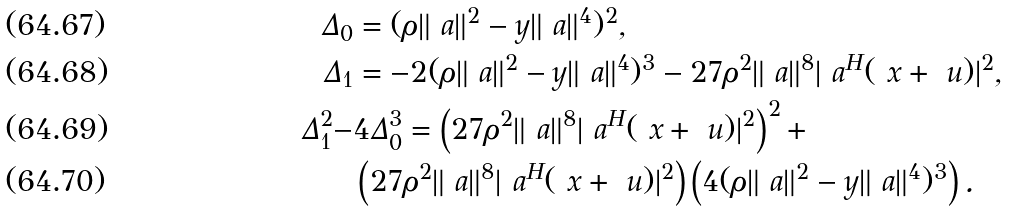<formula> <loc_0><loc_0><loc_500><loc_500>\Delta _ { 0 } & = ( \rho \| \ a \| ^ { 2 } - y \| \ a \| ^ { 4 } ) ^ { 2 } , \\ \Delta _ { 1 } & = - 2 ( \rho \| \ a \| ^ { 2 } - y \| \ a \| ^ { 4 } ) ^ { 3 } - 2 7 \rho ^ { 2 } \| \ a \| ^ { 8 } | \ a ^ { H } ( \ x + \ u ) | ^ { 2 } , \\ \Delta _ { 1 } ^ { 2 } - & 4 \Delta _ { 0 } ^ { 3 } = \left ( 2 7 \rho ^ { 2 } \| \ a \| ^ { 8 } | \ a ^ { H } ( \ x + \ u ) | ^ { 2 } \right ) ^ { 2 } + \\ & \left ( 2 7 \rho ^ { 2 } \| \ a \| ^ { 8 } | \ a ^ { H } ( \ x + \ u ) | ^ { 2 } \right ) \left ( 4 ( \rho \| \ a \| ^ { 2 } - y \| \ a \| ^ { 4 } ) ^ { 3 } \right ) .</formula> 